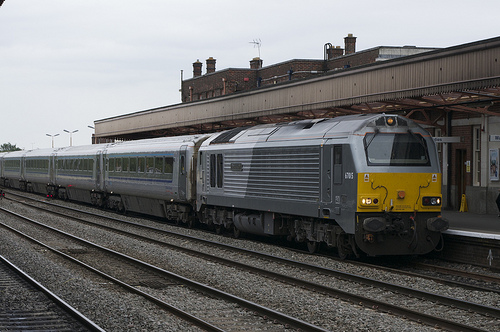Please provide a short description for this region: [0.0, 0.44, 0.38, 0.62]. The specified region covers large, grey train carts that are parked on the tracks. These carts feature a modern design with minimal detailing visible from this angle. 